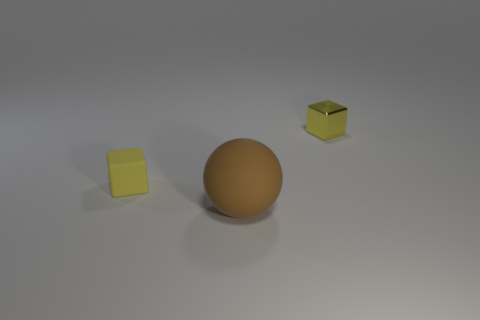Is the material of the brown sphere the same as the tiny yellow thing to the left of the ball?
Give a very brief answer. Yes. Are there more small yellow rubber objects that are in front of the yellow rubber block than small rubber cylinders?
Provide a short and direct response. No. What is the shape of the other tiny object that is the same color as the metallic object?
Offer a terse response. Cube. Are there any blocks that have the same material as the big brown thing?
Ensure brevity in your answer.  Yes. Is the cube behind the yellow rubber cube made of the same material as the yellow object on the left side of the metal cube?
Ensure brevity in your answer.  No. Are there an equal number of large rubber objects on the left side of the big rubber ball and small shiny cubes in front of the yellow shiny thing?
Offer a very short reply. Yes. There is a block that is the same size as the yellow metallic object; what is its color?
Make the answer very short. Yellow. Is there a big metallic object of the same color as the small matte block?
Your answer should be very brief. No. How many things are either tiny yellow things that are behind the rubber ball or yellow matte things?
Provide a succinct answer. 2. What number of other objects are the same size as the brown sphere?
Keep it short and to the point. 0. 